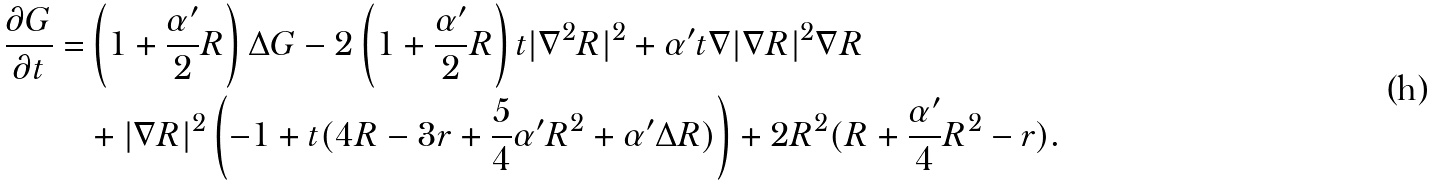Convert formula to latex. <formula><loc_0><loc_0><loc_500><loc_500>\frac { \partial G } { \partial t } = & \left ( 1 + \frac { \alpha ^ { \prime } } { 2 } R \right ) \Delta G - 2 \left ( 1 + \frac { \alpha ^ { \prime } } { 2 } R \right ) t | \nabla ^ { 2 } R | ^ { 2 } + \alpha ^ { \prime } t \nabla | \nabla R | ^ { 2 } \nabla R \\ & + | \nabla R | ^ { 2 } \left ( - 1 + t ( 4 R - 3 r + \frac { 5 } { 4 } \alpha ^ { \prime } R ^ { 2 } + \alpha ^ { \prime } \Delta R ) \right ) + 2 R ^ { 2 } ( R + \frac { \alpha ^ { \prime } } { 4 } R ^ { 2 } - r ) .</formula> 